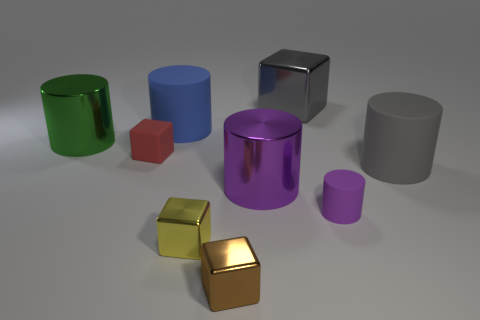Subtract all green cylinders. How many cylinders are left? 4 Subtract all blue rubber cylinders. How many cylinders are left? 4 Subtract all yellow cylinders. Subtract all cyan spheres. How many cylinders are left? 5 Add 1 purple metallic cylinders. How many objects exist? 10 Subtract all cylinders. How many objects are left? 4 Subtract 0 cyan spheres. How many objects are left? 9 Subtract all red rubber balls. Subtract all large gray rubber things. How many objects are left? 8 Add 1 big gray metallic blocks. How many big gray metallic blocks are left? 2 Add 3 green metal objects. How many green metal objects exist? 4 